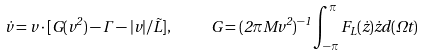Convert formula to latex. <formula><loc_0><loc_0><loc_500><loc_500>\dot { v } = v \cdot [ G ( v ^ { 2 } ) - \Gamma - | v | / \tilde { L } ] , \quad \ G = ( 2 \pi M v ^ { 2 } ) ^ { - 1 } \int _ { - \pi } ^ { \pi } { F _ { L } ( \dot { z } ) \dot { z } d ( \Omega t ) }</formula> 